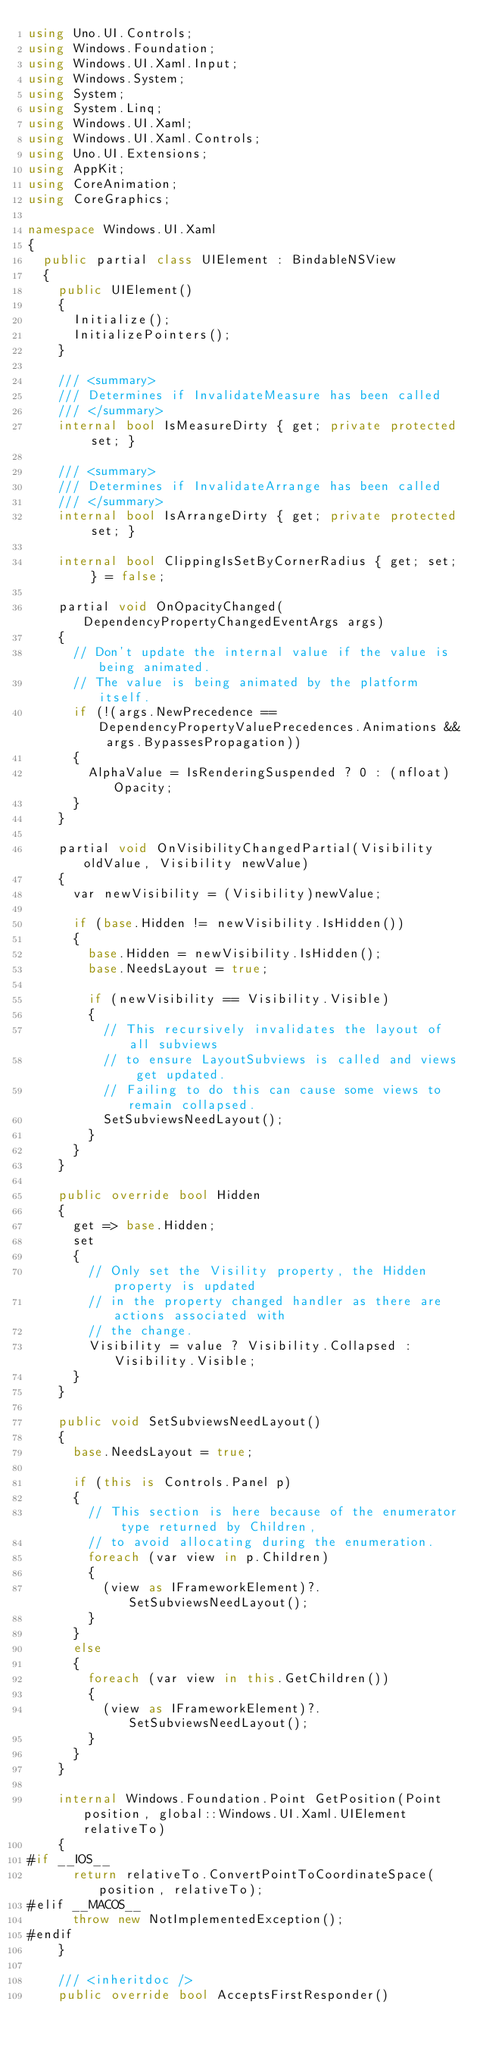Convert code to text. <code><loc_0><loc_0><loc_500><loc_500><_C#_>using Uno.UI.Controls;
using Windows.Foundation;
using Windows.UI.Xaml.Input;
using Windows.System;
using System;
using System.Linq;
using Windows.UI.Xaml;
using Windows.UI.Xaml.Controls;
using Uno.UI.Extensions;
using AppKit;
using CoreAnimation;
using CoreGraphics;

namespace Windows.UI.Xaml
{
	public partial class UIElement : BindableNSView
	{
		public UIElement()
		{
			Initialize();
			InitializePointers();
		}

		/// <summary>
		/// Determines if InvalidateMeasure has been called
		/// </summary>
		internal bool IsMeasureDirty { get; private protected set; }

		/// <summary>
		/// Determines if InvalidateArrange has been called
		/// </summary>
		internal bool IsArrangeDirty { get; private protected set; }

		internal bool ClippingIsSetByCornerRadius { get; set; } = false;

		partial void OnOpacityChanged(DependencyPropertyChangedEventArgs args)
		{
			// Don't update the internal value if the value is being animated.
			// The value is being animated by the platform itself.
			if (!(args.NewPrecedence == DependencyPropertyValuePrecedences.Animations && args.BypassesPropagation))
			{
				AlphaValue = IsRenderingSuspended ? 0 : (nfloat)Opacity;
			}
		}

		partial void OnVisibilityChangedPartial(Visibility oldValue, Visibility newValue)
		{
			var newVisibility = (Visibility)newValue;

			if (base.Hidden != newVisibility.IsHidden())
			{
				base.Hidden = newVisibility.IsHidden();
				base.NeedsLayout = true;

				if (newVisibility == Visibility.Visible)
				{
					// This recursively invalidates the layout of all subviews
					// to ensure LayoutSubviews is called and views get updated.
					// Failing to do this can cause some views to remain collapsed.
					SetSubviewsNeedLayout();
				}
			}
		}

		public override bool Hidden
		{
			get => base.Hidden;
			set
			{
				// Only set the Visility property, the Hidden property is updated
				// in the property changed handler as there are actions associated with
				// the change.
				Visibility = value ? Visibility.Collapsed : Visibility.Visible;
			}
		}

		public void SetSubviewsNeedLayout()
		{
			base.NeedsLayout = true;

			if (this is Controls.Panel p)
			{
				// This section is here because of the enumerator type returned by Children,
				// to avoid allocating during the enumeration.
				foreach (var view in p.Children)
				{
					(view as IFrameworkElement)?.SetSubviewsNeedLayout();
				}
			}
			else
			{
				foreach (var view in this.GetChildren())
				{
					(view as IFrameworkElement)?.SetSubviewsNeedLayout();
				}
			}
		}

		internal Windows.Foundation.Point GetPosition(Point position, global::Windows.UI.Xaml.UIElement relativeTo)
		{
#if __IOS__
			return relativeTo.ConvertPointToCoordinateSpace(position, relativeTo);
#elif __MACOS__
			throw new NotImplementedException();
#endif
		}

		/// <inheritdoc />
		public override bool AcceptsFirstResponder()</code> 